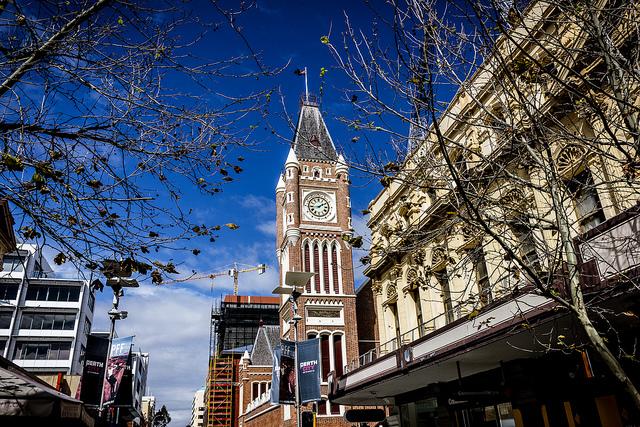Is the very noticeable structure centered in the image analog or digital?
Give a very brief answer. Analog. Does the tree have leaves?
Write a very short answer. Yes. Is this in a rural area?
Answer briefly. No. Are the trees leafy?
Short answer required. No. Is this a sunny day?
Concise answer only. Yes. 